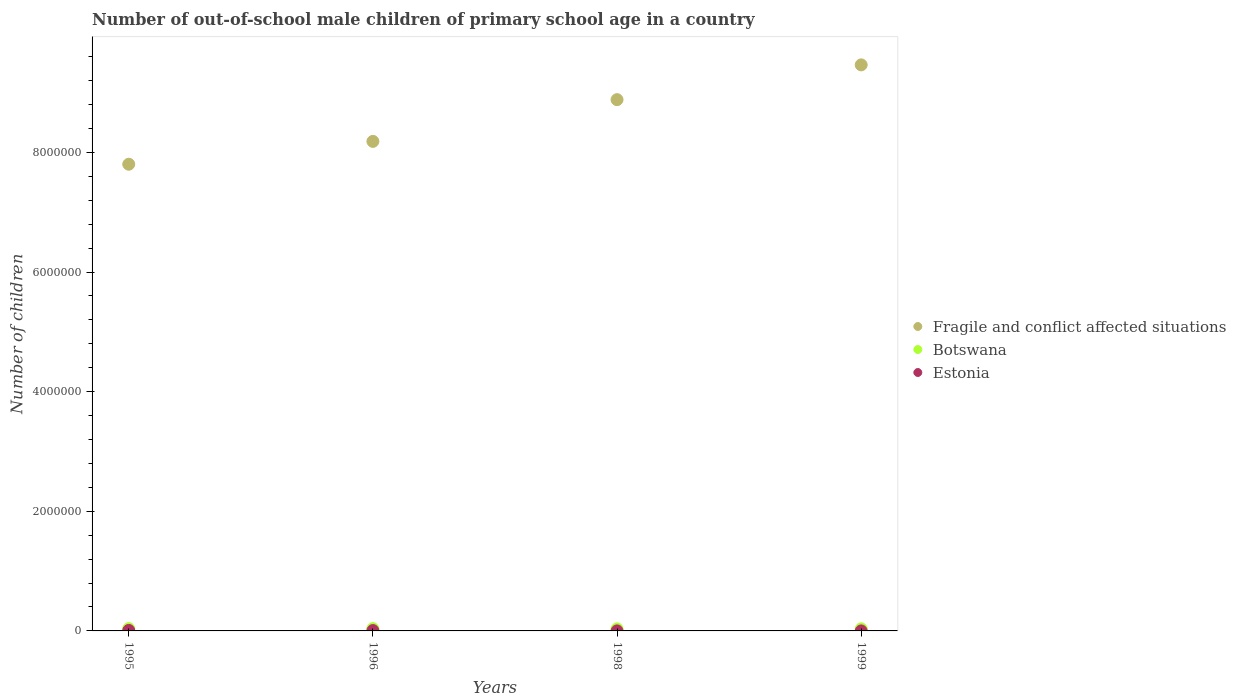Is the number of dotlines equal to the number of legend labels?
Offer a very short reply. Yes. What is the number of out-of-school male children in Botswana in 1996?
Provide a short and direct response. 3.82e+04. Across all years, what is the maximum number of out-of-school male children in Fragile and conflict affected situations?
Your answer should be very brief. 9.46e+06. In which year was the number of out-of-school male children in Botswana maximum?
Your answer should be compact. 1995. In which year was the number of out-of-school male children in Estonia minimum?
Your answer should be very brief. 1999. What is the total number of out-of-school male children in Fragile and conflict affected situations in the graph?
Your answer should be compact. 3.43e+07. What is the difference between the number of out-of-school male children in Botswana in 1998 and that in 1999?
Offer a very short reply. -469. What is the difference between the number of out-of-school male children in Estonia in 1995 and the number of out-of-school male children in Botswana in 1999?
Give a very brief answer. -2.65e+04. What is the average number of out-of-school male children in Botswana per year?
Make the answer very short. 3.65e+04. In the year 1996, what is the difference between the number of out-of-school male children in Estonia and number of out-of-school male children in Botswana?
Your response must be concise. -3.23e+04. What is the ratio of the number of out-of-school male children in Botswana in 1995 to that in 1996?
Your answer should be very brief. 1.01. Is the number of out-of-school male children in Botswana in 1998 less than that in 1999?
Offer a terse response. Yes. What is the difference between the highest and the second highest number of out-of-school male children in Botswana?
Your answer should be very brief. 314. What is the difference between the highest and the lowest number of out-of-school male children in Botswana?
Make the answer very short. 4181. In how many years, is the number of out-of-school male children in Estonia greater than the average number of out-of-school male children in Estonia taken over all years?
Offer a terse response. 2. Is the sum of the number of out-of-school male children in Fragile and conflict affected situations in 1995 and 1999 greater than the maximum number of out-of-school male children in Botswana across all years?
Provide a succinct answer. Yes. Is it the case that in every year, the sum of the number of out-of-school male children in Fragile and conflict affected situations and number of out-of-school male children in Botswana  is greater than the number of out-of-school male children in Estonia?
Your response must be concise. Yes. Is the number of out-of-school male children in Botswana strictly less than the number of out-of-school male children in Estonia over the years?
Your response must be concise. No. How many dotlines are there?
Your answer should be very brief. 3. How many years are there in the graph?
Offer a very short reply. 4. What is the difference between two consecutive major ticks on the Y-axis?
Your response must be concise. 2.00e+06. Are the values on the major ticks of Y-axis written in scientific E-notation?
Your answer should be compact. No. Does the graph contain grids?
Give a very brief answer. No. Where does the legend appear in the graph?
Your answer should be compact. Center right. What is the title of the graph?
Offer a terse response. Number of out-of-school male children of primary school age in a country. Does "Brunei Darussalam" appear as one of the legend labels in the graph?
Give a very brief answer. No. What is the label or title of the X-axis?
Offer a terse response. Years. What is the label or title of the Y-axis?
Your answer should be very brief. Number of children. What is the Number of children in Fragile and conflict affected situations in 1995?
Offer a terse response. 7.80e+06. What is the Number of children of Botswana in 1995?
Give a very brief answer. 3.85e+04. What is the Number of children of Estonia in 1995?
Offer a terse response. 8297. What is the Number of children of Fragile and conflict affected situations in 1996?
Provide a short and direct response. 8.18e+06. What is the Number of children of Botswana in 1996?
Your response must be concise. 3.82e+04. What is the Number of children of Estonia in 1996?
Give a very brief answer. 5863. What is the Number of children of Fragile and conflict affected situations in 1998?
Offer a very short reply. 8.88e+06. What is the Number of children in Botswana in 1998?
Ensure brevity in your answer.  3.43e+04. What is the Number of children in Estonia in 1998?
Offer a very short reply. 334. What is the Number of children of Fragile and conflict affected situations in 1999?
Offer a very short reply. 9.46e+06. What is the Number of children in Botswana in 1999?
Your answer should be very brief. 3.48e+04. Across all years, what is the maximum Number of children in Fragile and conflict affected situations?
Make the answer very short. 9.46e+06. Across all years, what is the maximum Number of children in Botswana?
Provide a succinct answer. 3.85e+04. Across all years, what is the maximum Number of children of Estonia?
Keep it short and to the point. 8297. Across all years, what is the minimum Number of children in Fragile and conflict affected situations?
Make the answer very short. 7.80e+06. Across all years, what is the minimum Number of children of Botswana?
Give a very brief answer. 3.43e+04. What is the total Number of children of Fragile and conflict affected situations in the graph?
Make the answer very short. 3.43e+07. What is the total Number of children in Botswana in the graph?
Ensure brevity in your answer.  1.46e+05. What is the total Number of children in Estonia in the graph?
Give a very brief answer. 1.45e+04. What is the difference between the Number of children in Fragile and conflict affected situations in 1995 and that in 1996?
Make the answer very short. -3.82e+05. What is the difference between the Number of children in Botswana in 1995 and that in 1996?
Offer a very short reply. 314. What is the difference between the Number of children in Estonia in 1995 and that in 1996?
Provide a succinct answer. 2434. What is the difference between the Number of children in Fragile and conflict affected situations in 1995 and that in 1998?
Your answer should be compact. -1.08e+06. What is the difference between the Number of children in Botswana in 1995 and that in 1998?
Offer a terse response. 4181. What is the difference between the Number of children in Estonia in 1995 and that in 1998?
Your answer should be very brief. 7963. What is the difference between the Number of children in Fragile and conflict affected situations in 1995 and that in 1999?
Provide a succinct answer. -1.66e+06. What is the difference between the Number of children in Botswana in 1995 and that in 1999?
Your answer should be compact. 3712. What is the difference between the Number of children in Estonia in 1995 and that in 1999?
Ensure brevity in your answer.  8270. What is the difference between the Number of children of Fragile and conflict affected situations in 1996 and that in 1998?
Provide a short and direct response. -6.98e+05. What is the difference between the Number of children of Botswana in 1996 and that in 1998?
Your response must be concise. 3867. What is the difference between the Number of children in Estonia in 1996 and that in 1998?
Give a very brief answer. 5529. What is the difference between the Number of children of Fragile and conflict affected situations in 1996 and that in 1999?
Provide a short and direct response. -1.28e+06. What is the difference between the Number of children in Botswana in 1996 and that in 1999?
Provide a succinct answer. 3398. What is the difference between the Number of children in Estonia in 1996 and that in 1999?
Your response must be concise. 5836. What is the difference between the Number of children of Fragile and conflict affected situations in 1998 and that in 1999?
Your response must be concise. -5.81e+05. What is the difference between the Number of children in Botswana in 1998 and that in 1999?
Offer a very short reply. -469. What is the difference between the Number of children in Estonia in 1998 and that in 1999?
Your answer should be very brief. 307. What is the difference between the Number of children of Fragile and conflict affected situations in 1995 and the Number of children of Botswana in 1996?
Your answer should be compact. 7.76e+06. What is the difference between the Number of children of Fragile and conflict affected situations in 1995 and the Number of children of Estonia in 1996?
Your answer should be compact. 7.80e+06. What is the difference between the Number of children of Botswana in 1995 and the Number of children of Estonia in 1996?
Your response must be concise. 3.27e+04. What is the difference between the Number of children in Fragile and conflict affected situations in 1995 and the Number of children in Botswana in 1998?
Give a very brief answer. 7.77e+06. What is the difference between the Number of children in Fragile and conflict affected situations in 1995 and the Number of children in Estonia in 1998?
Give a very brief answer. 7.80e+06. What is the difference between the Number of children of Botswana in 1995 and the Number of children of Estonia in 1998?
Offer a very short reply. 3.82e+04. What is the difference between the Number of children in Fragile and conflict affected situations in 1995 and the Number of children in Botswana in 1999?
Keep it short and to the point. 7.77e+06. What is the difference between the Number of children of Fragile and conflict affected situations in 1995 and the Number of children of Estonia in 1999?
Provide a short and direct response. 7.80e+06. What is the difference between the Number of children in Botswana in 1995 and the Number of children in Estonia in 1999?
Your answer should be compact. 3.85e+04. What is the difference between the Number of children in Fragile and conflict affected situations in 1996 and the Number of children in Botswana in 1998?
Keep it short and to the point. 8.15e+06. What is the difference between the Number of children of Fragile and conflict affected situations in 1996 and the Number of children of Estonia in 1998?
Offer a terse response. 8.18e+06. What is the difference between the Number of children of Botswana in 1996 and the Number of children of Estonia in 1998?
Your response must be concise. 3.79e+04. What is the difference between the Number of children of Fragile and conflict affected situations in 1996 and the Number of children of Botswana in 1999?
Provide a short and direct response. 8.15e+06. What is the difference between the Number of children in Fragile and conflict affected situations in 1996 and the Number of children in Estonia in 1999?
Keep it short and to the point. 8.18e+06. What is the difference between the Number of children of Botswana in 1996 and the Number of children of Estonia in 1999?
Your response must be concise. 3.82e+04. What is the difference between the Number of children in Fragile and conflict affected situations in 1998 and the Number of children in Botswana in 1999?
Ensure brevity in your answer.  8.85e+06. What is the difference between the Number of children of Fragile and conflict affected situations in 1998 and the Number of children of Estonia in 1999?
Offer a very short reply. 8.88e+06. What is the difference between the Number of children in Botswana in 1998 and the Number of children in Estonia in 1999?
Ensure brevity in your answer.  3.43e+04. What is the average Number of children of Fragile and conflict affected situations per year?
Offer a terse response. 8.58e+06. What is the average Number of children in Botswana per year?
Your answer should be very brief. 3.65e+04. What is the average Number of children in Estonia per year?
Make the answer very short. 3630.25. In the year 1995, what is the difference between the Number of children of Fragile and conflict affected situations and Number of children of Botswana?
Your answer should be very brief. 7.76e+06. In the year 1995, what is the difference between the Number of children in Fragile and conflict affected situations and Number of children in Estonia?
Provide a succinct answer. 7.79e+06. In the year 1995, what is the difference between the Number of children in Botswana and Number of children in Estonia?
Ensure brevity in your answer.  3.02e+04. In the year 1996, what is the difference between the Number of children in Fragile and conflict affected situations and Number of children in Botswana?
Offer a very short reply. 8.15e+06. In the year 1996, what is the difference between the Number of children of Fragile and conflict affected situations and Number of children of Estonia?
Offer a terse response. 8.18e+06. In the year 1996, what is the difference between the Number of children of Botswana and Number of children of Estonia?
Ensure brevity in your answer.  3.23e+04. In the year 1998, what is the difference between the Number of children in Fragile and conflict affected situations and Number of children in Botswana?
Your response must be concise. 8.85e+06. In the year 1998, what is the difference between the Number of children of Fragile and conflict affected situations and Number of children of Estonia?
Provide a short and direct response. 8.88e+06. In the year 1998, what is the difference between the Number of children in Botswana and Number of children in Estonia?
Your answer should be compact. 3.40e+04. In the year 1999, what is the difference between the Number of children of Fragile and conflict affected situations and Number of children of Botswana?
Ensure brevity in your answer.  9.43e+06. In the year 1999, what is the difference between the Number of children of Fragile and conflict affected situations and Number of children of Estonia?
Your answer should be compact. 9.46e+06. In the year 1999, what is the difference between the Number of children in Botswana and Number of children in Estonia?
Keep it short and to the point. 3.48e+04. What is the ratio of the Number of children of Fragile and conflict affected situations in 1995 to that in 1996?
Ensure brevity in your answer.  0.95. What is the ratio of the Number of children of Botswana in 1995 to that in 1996?
Your answer should be very brief. 1.01. What is the ratio of the Number of children in Estonia in 1995 to that in 1996?
Your response must be concise. 1.42. What is the ratio of the Number of children in Fragile and conflict affected situations in 1995 to that in 1998?
Your answer should be compact. 0.88. What is the ratio of the Number of children in Botswana in 1995 to that in 1998?
Offer a terse response. 1.12. What is the ratio of the Number of children of Estonia in 1995 to that in 1998?
Your response must be concise. 24.84. What is the ratio of the Number of children in Fragile and conflict affected situations in 1995 to that in 1999?
Your answer should be very brief. 0.82. What is the ratio of the Number of children of Botswana in 1995 to that in 1999?
Your answer should be very brief. 1.11. What is the ratio of the Number of children in Estonia in 1995 to that in 1999?
Provide a short and direct response. 307.3. What is the ratio of the Number of children of Fragile and conflict affected situations in 1996 to that in 1998?
Offer a very short reply. 0.92. What is the ratio of the Number of children of Botswana in 1996 to that in 1998?
Your answer should be very brief. 1.11. What is the ratio of the Number of children in Estonia in 1996 to that in 1998?
Offer a terse response. 17.55. What is the ratio of the Number of children in Fragile and conflict affected situations in 1996 to that in 1999?
Provide a short and direct response. 0.86. What is the ratio of the Number of children in Botswana in 1996 to that in 1999?
Your answer should be very brief. 1.1. What is the ratio of the Number of children in Estonia in 1996 to that in 1999?
Give a very brief answer. 217.15. What is the ratio of the Number of children in Fragile and conflict affected situations in 1998 to that in 1999?
Provide a succinct answer. 0.94. What is the ratio of the Number of children of Botswana in 1998 to that in 1999?
Make the answer very short. 0.99. What is the ratio of the Number of children in Estonia in 1998 to that in 1999?
Offer a terse response. 12.37. What is the difference between the highest and the second highest Number of children in Fragile and conflict affected situations?
Keep it short and to the point. 5.81e+05. What is the difference between the highest and the second highest Number of children in Botswana?
Give a very brief answer. 314. What is the difference between the highest and the second highest Number of children in Estonia?
Give a very brief answer. 2434. What is the difference between the highest and the lowest Number of children of Fragile and conflict affected situations?
Give a very brief answer. 1.66e+06. What is the difference between the highest and the lowest Number of children of Botswana?
Keep it short and to the point. 4181. What is the difference between the highest and the lowest Number of children in Estonia?
Keep it short and to the point. 8270. 